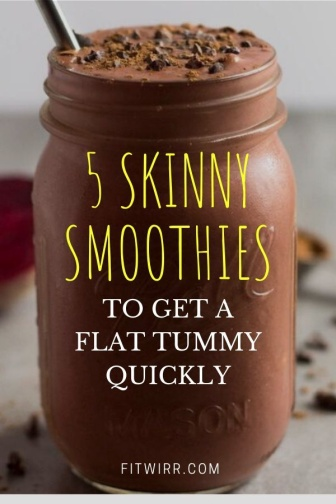Can you elaborate on the elements of the picture provided? Certainly! The image showcases a mason jar with a rustic appearance, filled with a chocolate smoothie. The jar has a prominent label with yellow text that reads '5 SKINNY SMOOTHIES TO GET A FLAT TUMMY QUICKLY,' suggesting that the smoothie is not only tasty but also aligned with health and wellness goals. The text is presented on a clear label that allows the smoothie's color to show through, providing a visually appealing contrast. 

Visible texture in the smoothie hints at a thick and possibly creamy consistency, appealing to those who enjoy indulgent but healthy options. A metal straw inserted into the jar suggests eco-friendliness and readiness to enjoy the drink. The countertop beneath the jar presents a clean and neutral setting, with a scattering of chocolate chips and a single raspberry, adding a playful and appetizing touch without detracting from the main focus. These elements combine to give the impression of a well-considered composition designed to be as enticing as it is suggestive of a healthy lifestyle choice. 